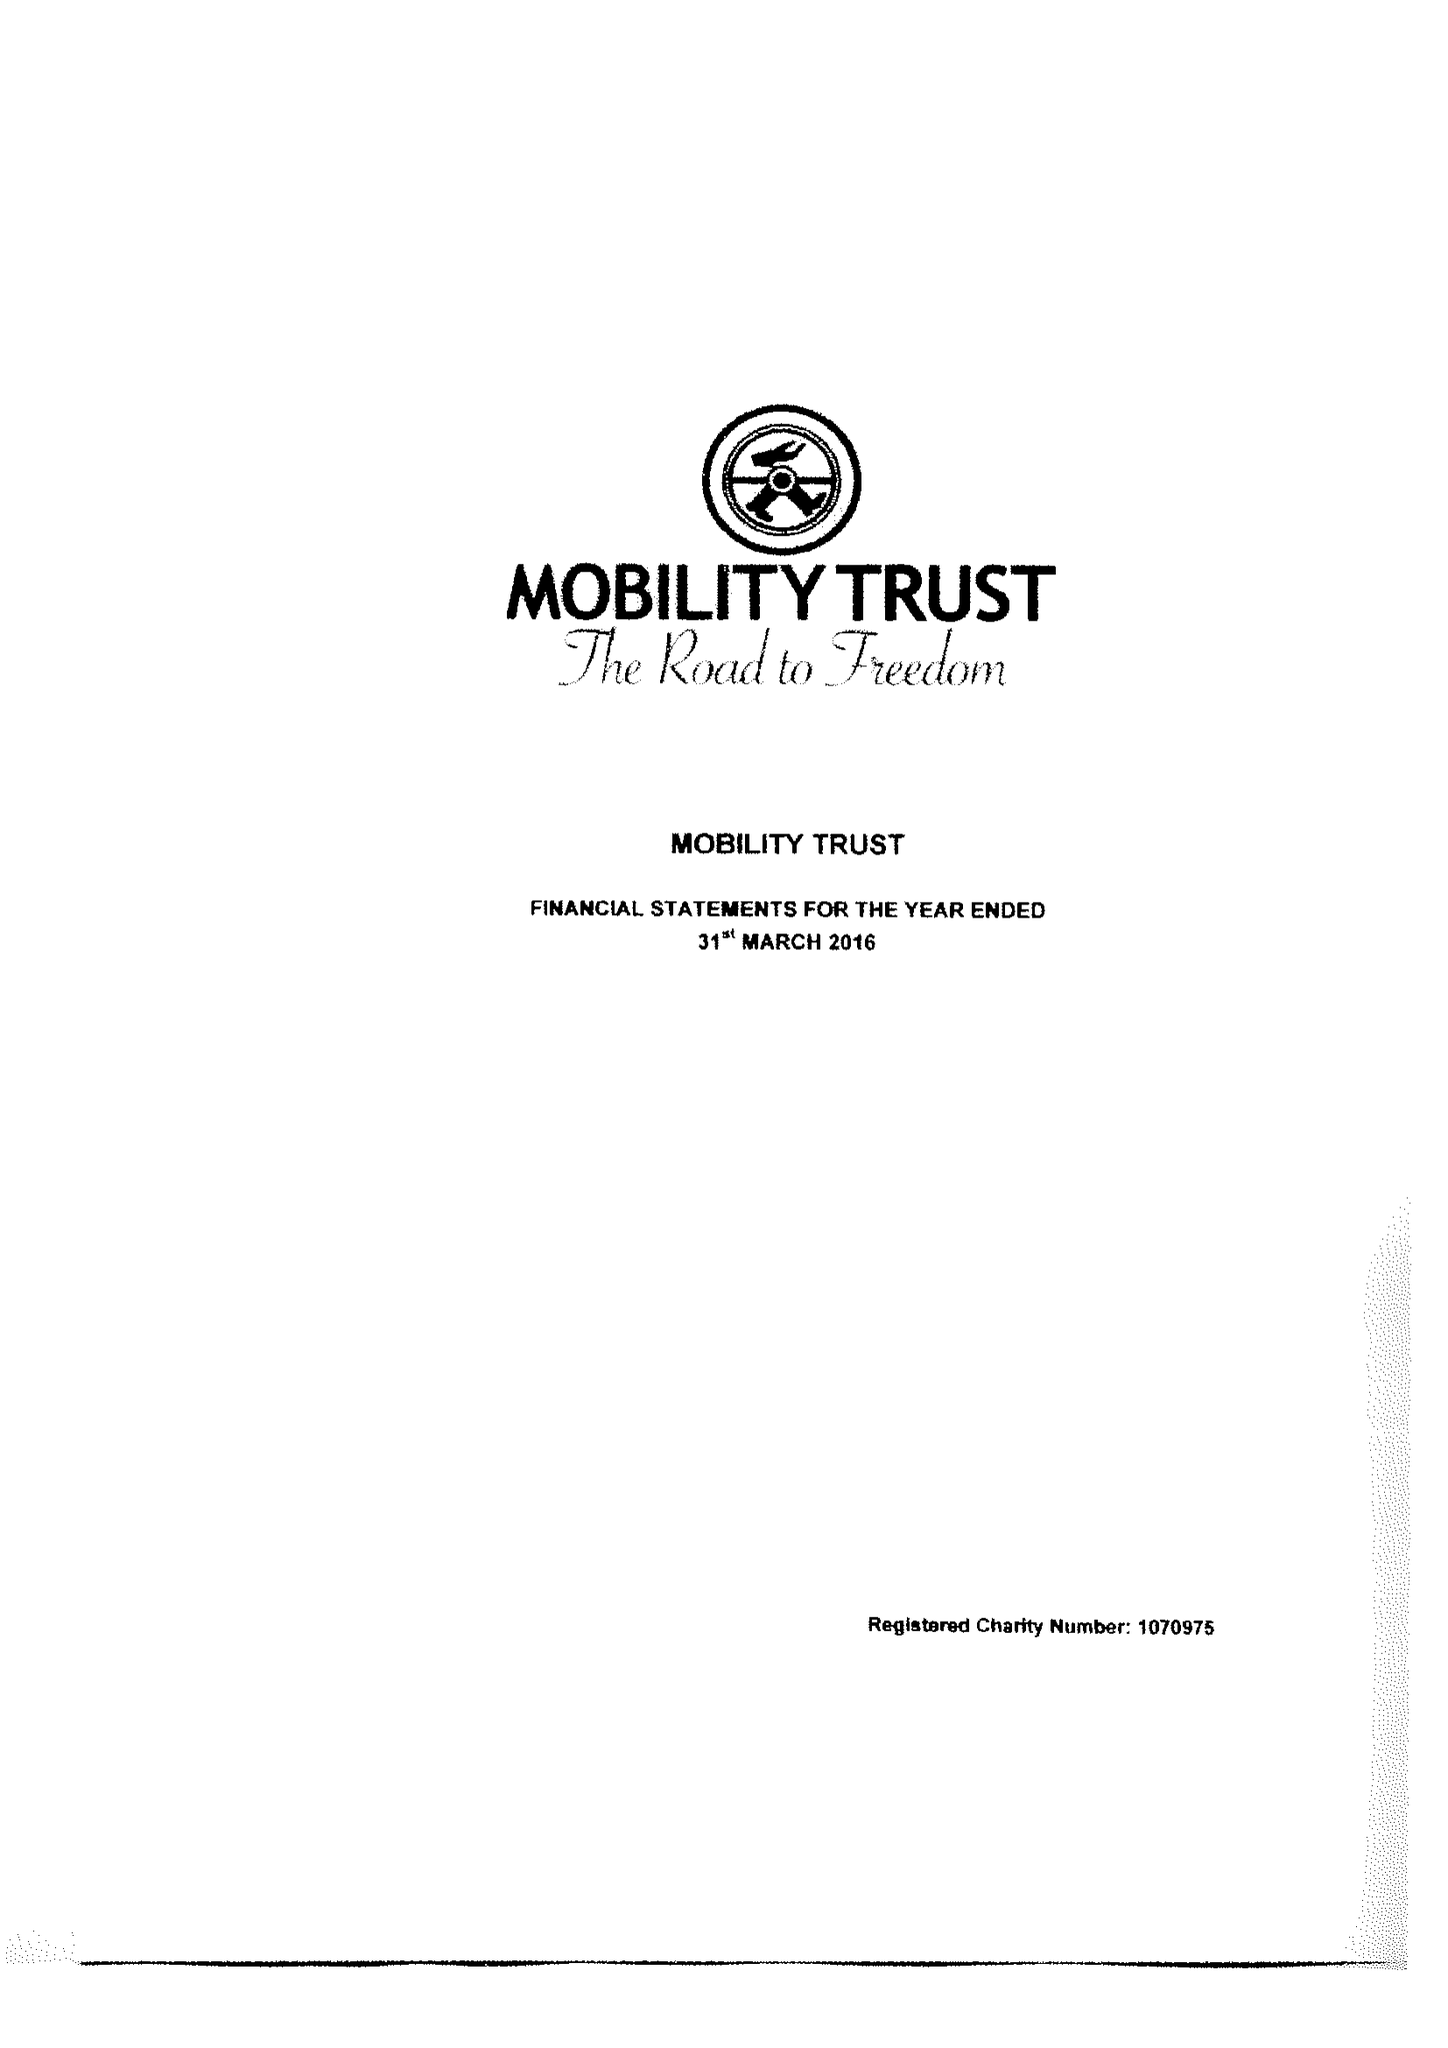What is the value for the report_date?
Answer the question using a single word or phrase. 2016-03-31 